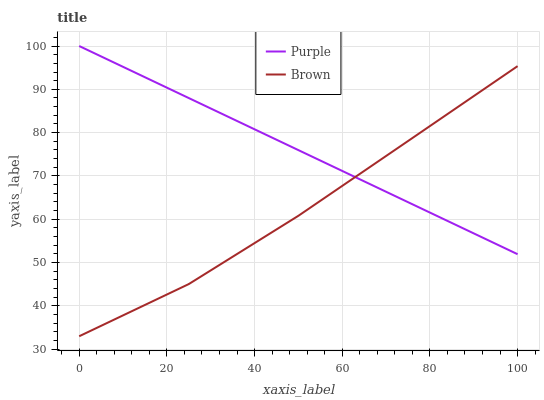Does Brown have the minimum area under the curve?
Answer yes or no. Yes. Does Purple have the maximum area under the curve?
Answer yes or no. Yes. Does Brown have the maximum area under the curve?
Answer yes or no. No. Is Purple the smoothest?
Answer yes or no. Yes. Is Brown the roughest?
Answer yes or no. Yes. Is Brown the smoothest?
Answer yes or no. No. Does Brown have the lowest value?
Answer yes or no. Yes. Does Purple have the highest value?
Answer yes or no. Yes. Does Brown have the highest value?
Answer yes or no. No. Does Purple intersect Brown?
Answer yes or no. Yes. Is Purple less than Brown?
Answer yes or no. No. Is Purple greater than Brown?
Answer yes or no. No. 